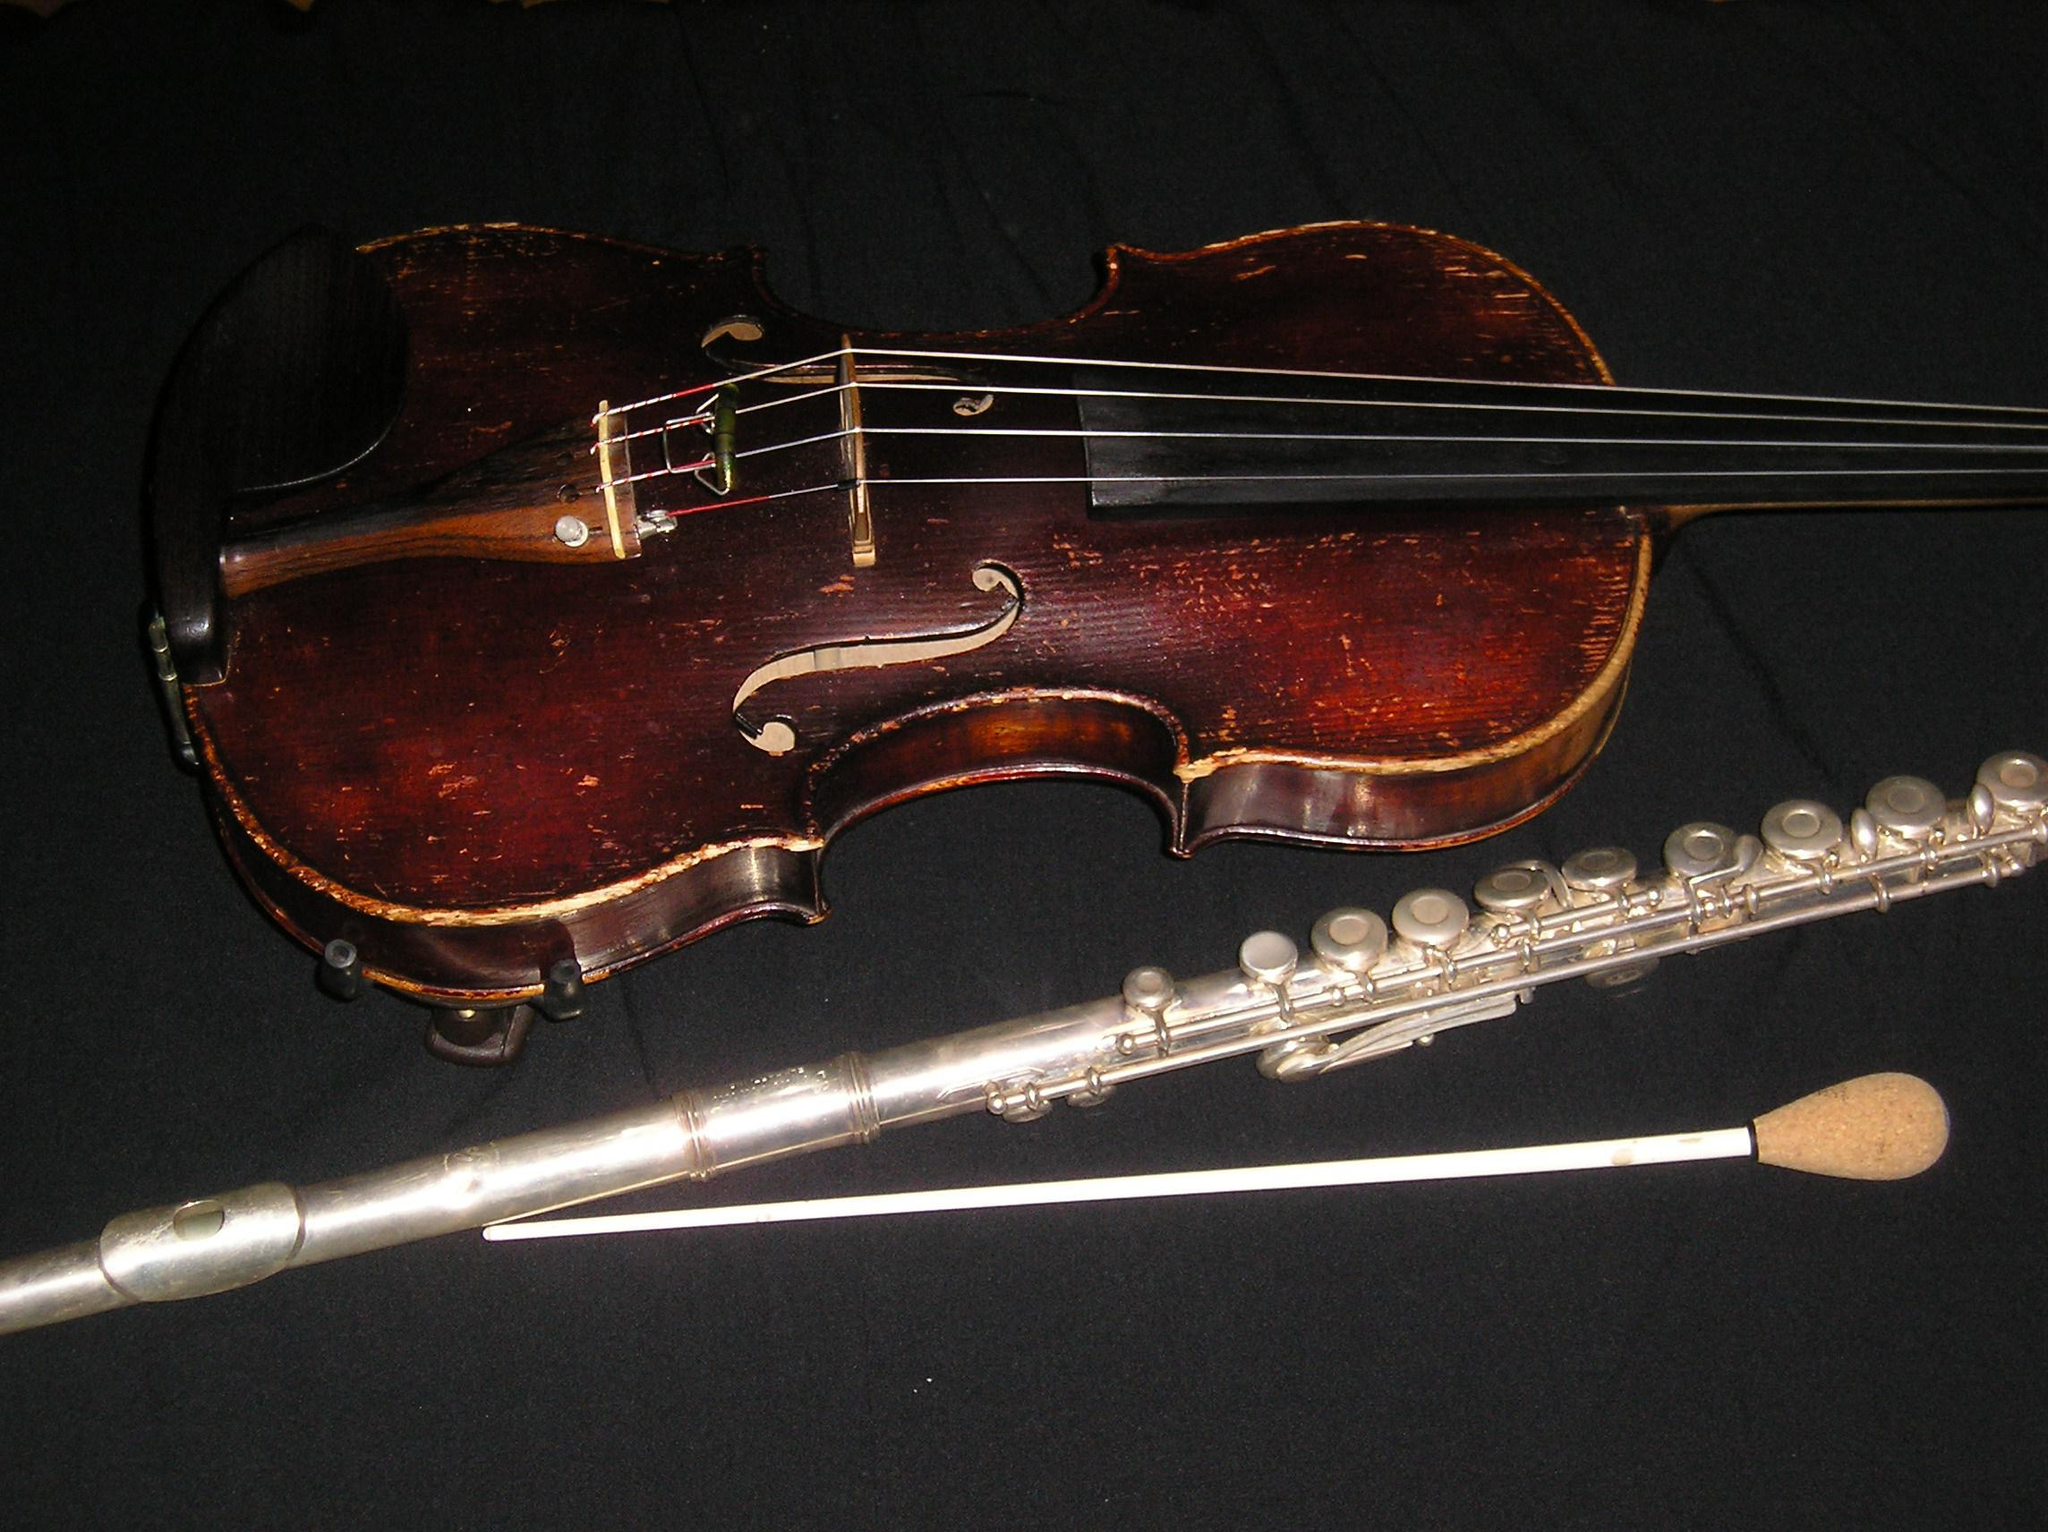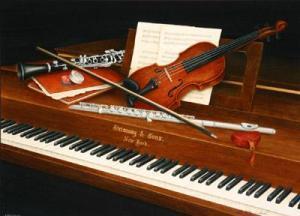The first image is the image on the left, the second image is the image on the right. Considering the images on both sides, is "A violin bow is touching violin strings and a flute." valid? Answer yes or no. No. The first image is the image on the left, the second image is the image on the right. For the images shown, is this caption "An image features items displayed overlapping on a flat surface, including a violin, sheet music, and a straight wind instrument in pieces." true? Answer yes or no. No. 